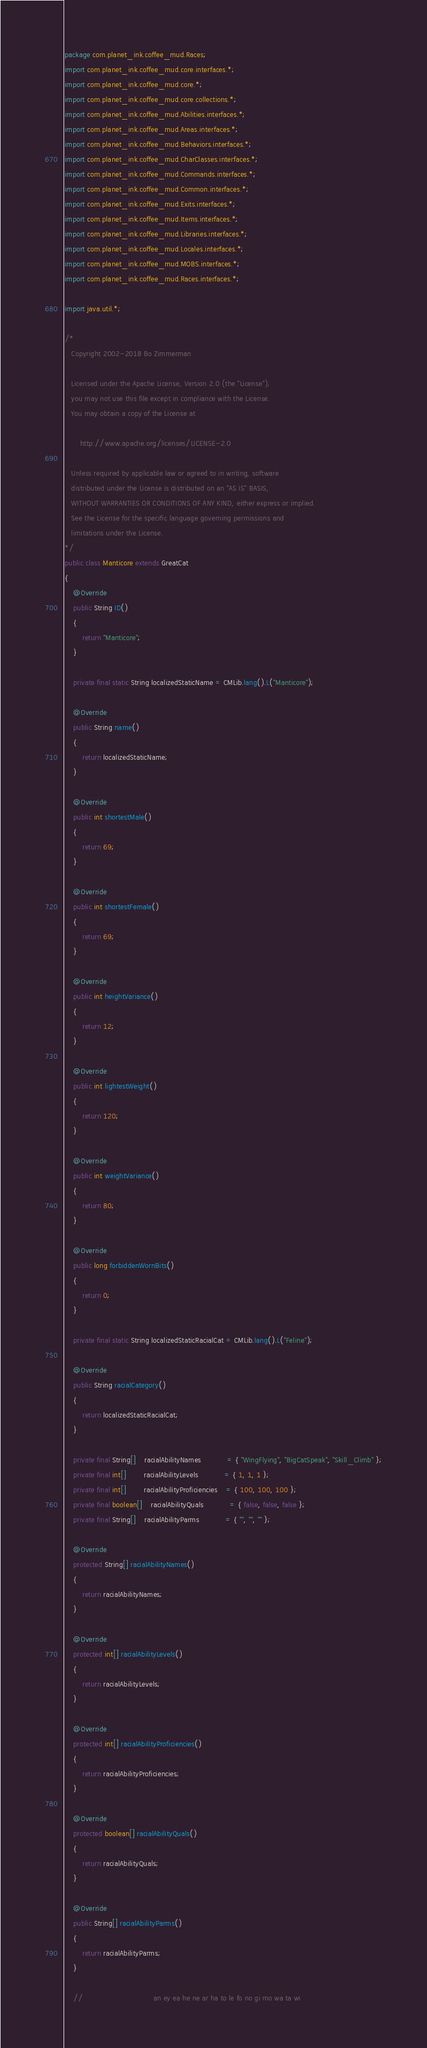Convert code to text. <code><loc_0><loc_0><loc_500><loc_500><_Java_>package com.planet_ink.coffee_mud.Races;
import com.planet_ink.coffee_mud.core.interfaces.*;
import com.planet_ink.coffee_mud.core.*;
import com.planet_ink.coffee_mud.core.collections.*;
import com.planet_ink.coffee_mud.Abilities.interfaces.*;
import com.planet_ink.coffee_mud.Areas.interfaces.*;
import com.planet_ink.coffee_mud.Behaviors.interfaces.*;
import com.planet_ink.coffee_mud.CharClasses.interfaces.*;
import com.planet_ink.coffee_mud.Commands.interfaces.*;
import com.planet_ink.coffee_mud.Common.interfaces.*;
import com.planet_ink.coffee_mud.Exits.interfaces.*;
import com.planet_ink.coffee_mud.Items.interfaces.*;
import com.planet_ink.coffee_mud.Libraries.interfaces.*;
import com.planet_ink.coffee_mud.Locales.interfaces.*;
import com.planet_ink.coffee_mud.MOBS.interfaces.*;
import com.planet_ink.coffee_mud.Races.interfaces.*;

import java.util.*;

/*
   Copyright 2002-2018 Bo Zimmerman

   Licensed under the Apache License, Version 2.0 (the "License");
   you may not use this file except in compliance with the License.
   You may obtain a copy of the License at

	   http://www.apache.org/licenses/LICENSE-2.0

   Unless required by applicable law or agreed to in writing, software
   distributed under the License is distributed on an "AS IS" BASIS,
   WITHOUT WARRANTIES OR CONDITIONS OF ANY KIND, either express or implied.
   See the License for the specific language governing permissions and
   limitations under the License.
*/
public class Manticore extends GreatCat
{
	@Override
	public String ID()
	{
		return "Manticore";
	}

	private final static String localizedStaticName = CMLib.lang().L("Manticore");

	@Override
	public String name()
	{
		return localizedStaticName;
	}

	@Override
	public int shortestMale()
	{
		return 69;
	}

	@Override
	public int shortestFemale()
	{
		return 69;
	}

	@Override
	public int heightVariance()
	{
		return 12;
	}

	@Override
	public int lightestWeight()
	{
		return 120;
	}

	@Override
	public int weightVariance()
	{
		return 80;
	}

	@Override
	public long forbiddenWornBits()
	{
		return 0;
	}

	private final static String localizedStaticRacialCat = CMLib.lang().L("Feline");

	@Override
	public String racialCategory()
	{
		return localizedStaticRacialCat;
	}

	private final String[]	racialAbilityNames			= { "WingFlying", "BigCatSpeak", "Skill_Climb" };
	private final int[]		racialAbilityLevels			= { 1, 1, 1 };
	private final int[]		racialAbilityProficiencies	= { 100, 100, 100 };
	private final boolean[]	racialAbilityQuals			= { false, false, false };
	private final String[]	racialAbilityParms			= { "", "", "" };

	@Override
	protected String[] racialAbilityNames()
	{
		return racialAbilityNames;
	}

	@Override
	protected int[] racialAbilityLevels()
	{
		return racialAbilityLevels;
	}

	@Override
	protected int[] racialAbilityProficiencies()
	{
		return racialAbilityProficiencies;
	}

	@Override
	protected boolean[] racialAbilityQuals()
	{
		return racialAbilityQuals;
	}

	@Override
	public String[] racialAbilityParms()
	{
		return racialAbilityParms;
	}

	//  							  an ey ea he ne ar ha to le fo no gi mo wa ta wi</code> 